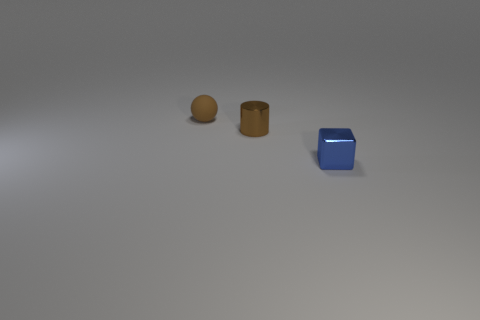Is the number of tiny blocks greater than the number of large brown cubes?
Ensure brevity in your answer.  Yes. What material is the brown ball?
Offer a terse response. Rubber. Are there any blue shiny blocks that are behind the shiny object left of the tiny blue object?
Your answer should be compact. No. Is the color of the small ball the same as the cylinder?
Provide a short and direct response. Yes. What number of other things are there of the same shape as the tiny brown metallic thing?
Keep it short and to the point. 0. Are there more small cylinders behind the small brown sphere than tiny brown metal cylinders behind the small metallic block?
Offer a very short reply. No. There is a metal object that is left of the small blue metallic block; is it the same size as the brown object to the left of the brown cylinder?
Your response must be concise. Yes. The small blue thing is what shape?
Ensure brevity in your answer.  Cube. What is the color of the small cube that is made of the same material as the brown cylinder?
Provide a short and direct response. Blue. Are the tiny brown cylinder and the brown object behind the small brown metal cylinder made of the same material?
Ensure brevity in your answer.  No. 